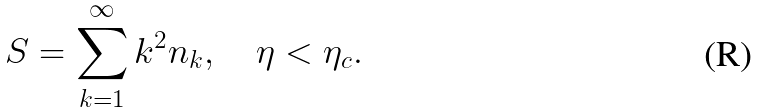Convert formula to latex. <formula><loc_0><loc_0><loc_500><loc_500>S = \sum _ { k = 1 } ^ { \infty } k ^ { 2 } n _ { k } , \quad \eta < \eta _ { c } .</formula> 